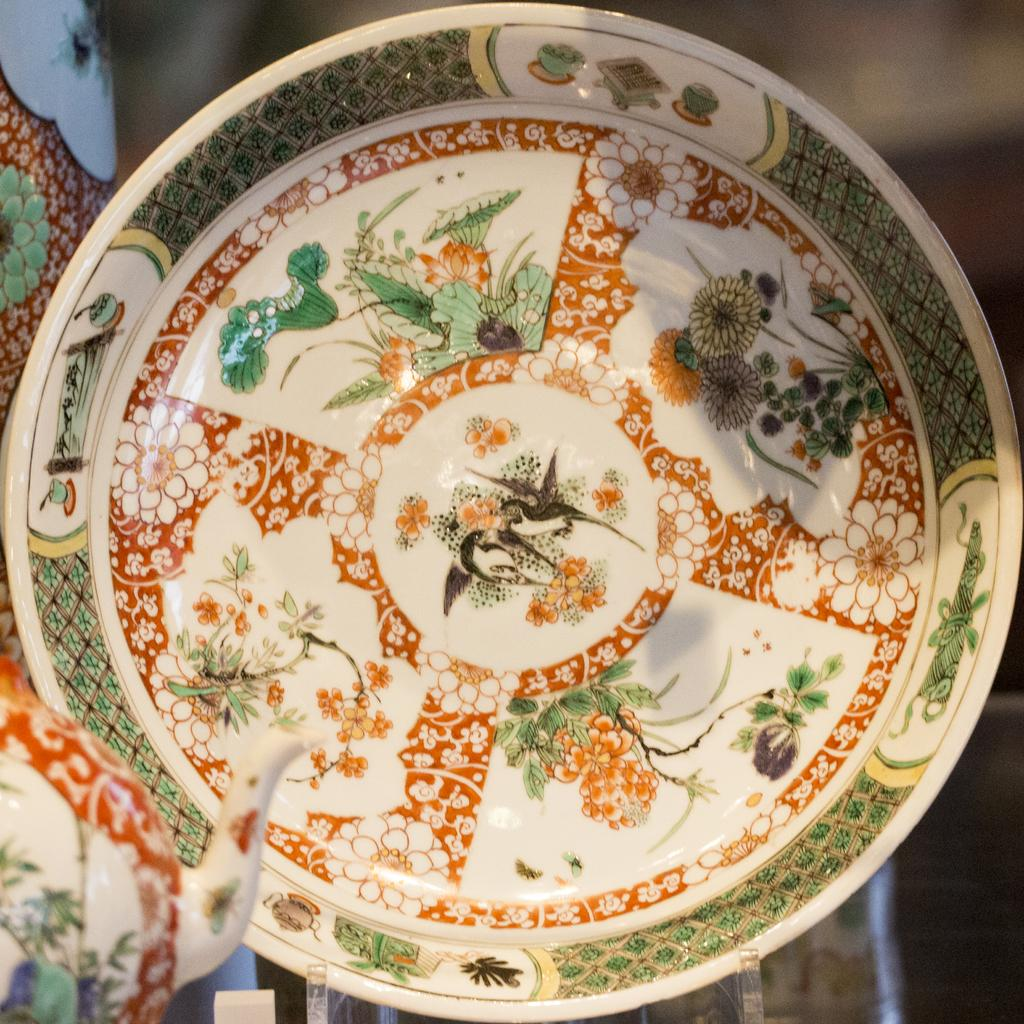What object can be seen in the image? There is a plate in the image. What is on the plate? The plate contains colorful designs. Can you hear the sleet hitting the plate in the image? There is no mention of sleet or any sound in the image, so it cannot be heard. 